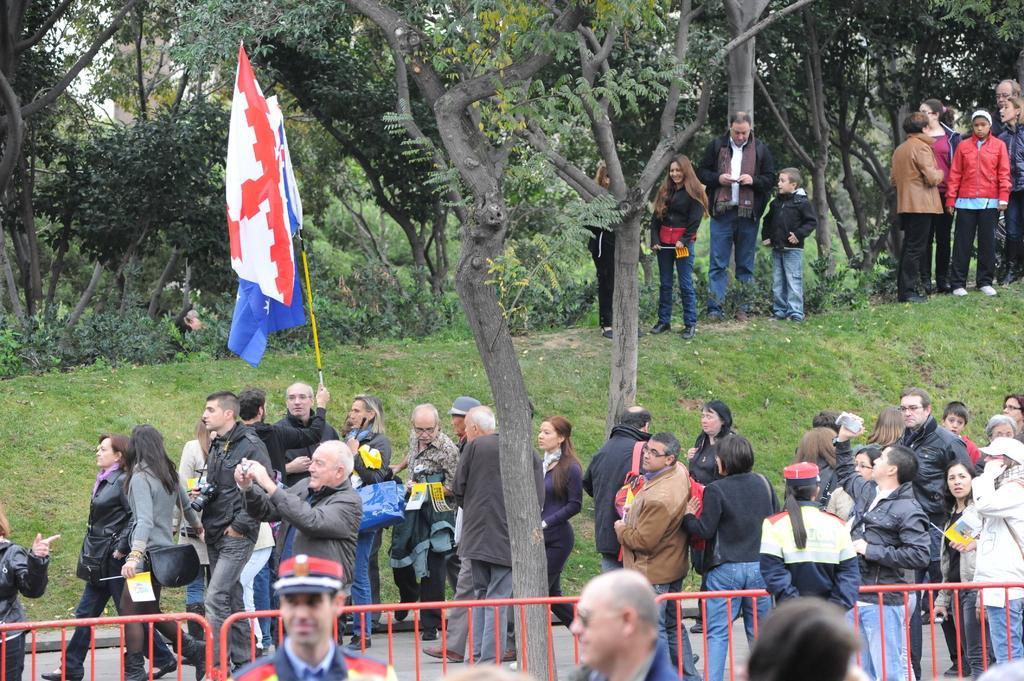Can you describe this image briefly? This picture describes about group of people, few are standing on the grass, and few are walking on the pathway, and we can see a man is holding a flag, beside to them we can find fence and trees. 